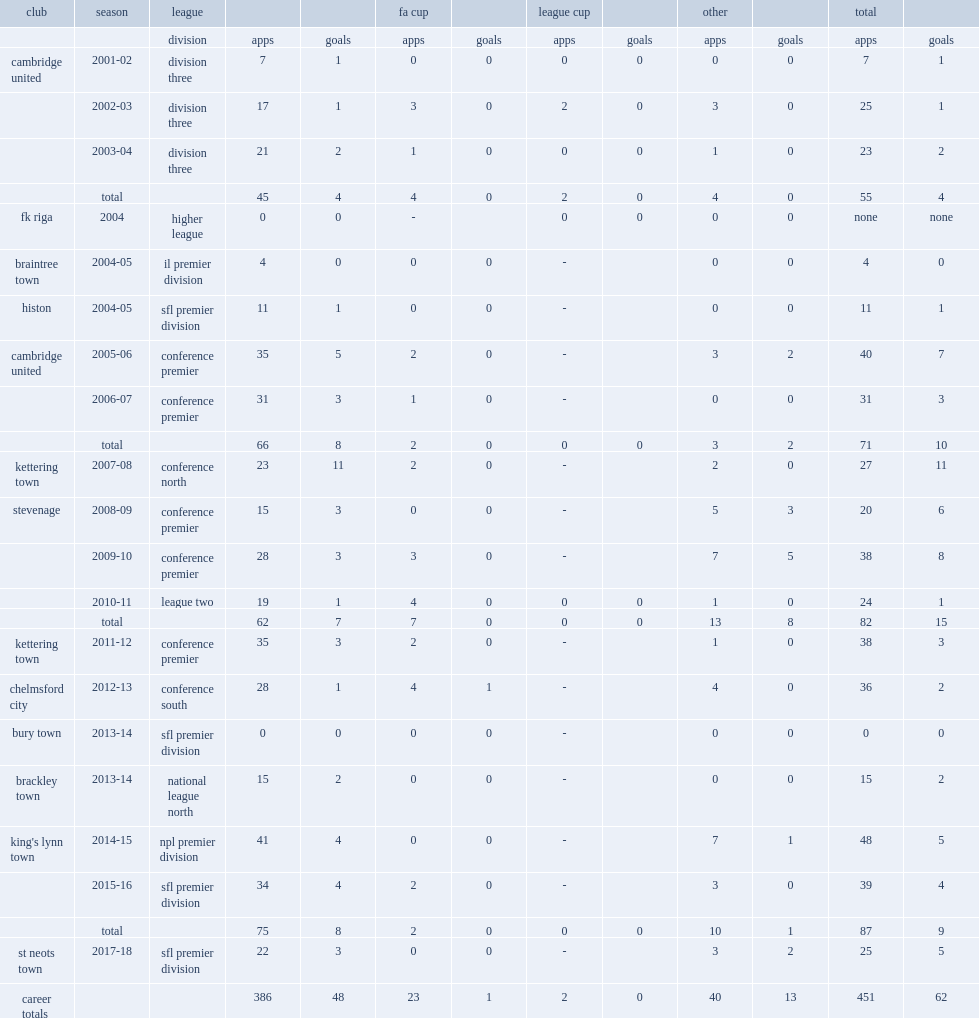Which goal did david bridges score his goal for stevenage in the 2009-10 conference premier league? 8.0. In 2007-08 season, which league did bridges join kettering town in? Conference north. 